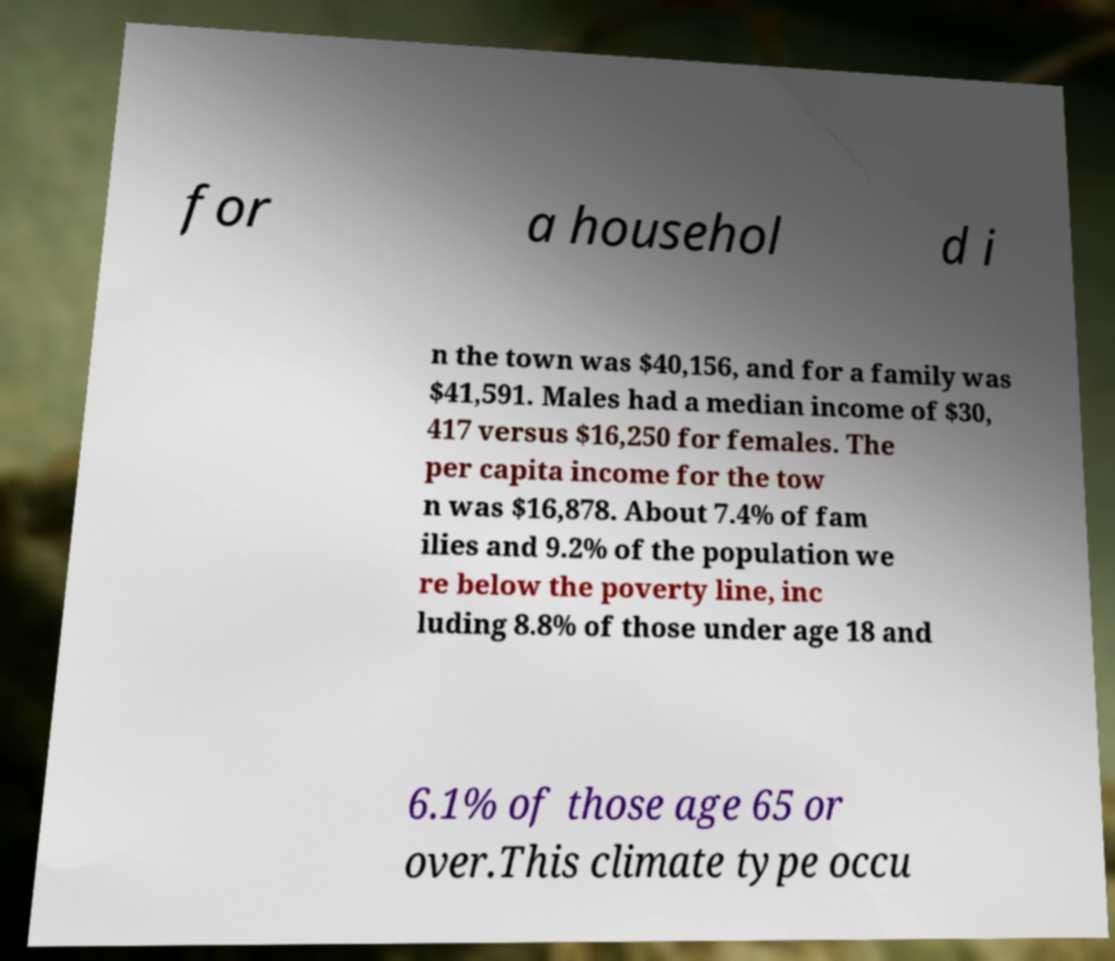Can you read and provide the text displayed in the image?This photo seems to have some interesting text. Can you extract and type it out for me? for a househol d i n the town was $40,156, and for a family was $41,591. Males had a median income of $30, 417 versus $16,250 for females. The per capita income for the tow n was $16,878. About 7.4% of fam ilies and 9.2% of the population we re below the poverty line, inc luding 8.8% of those under age 18 and 6.1% of those age 65 or over.This climate type occu 